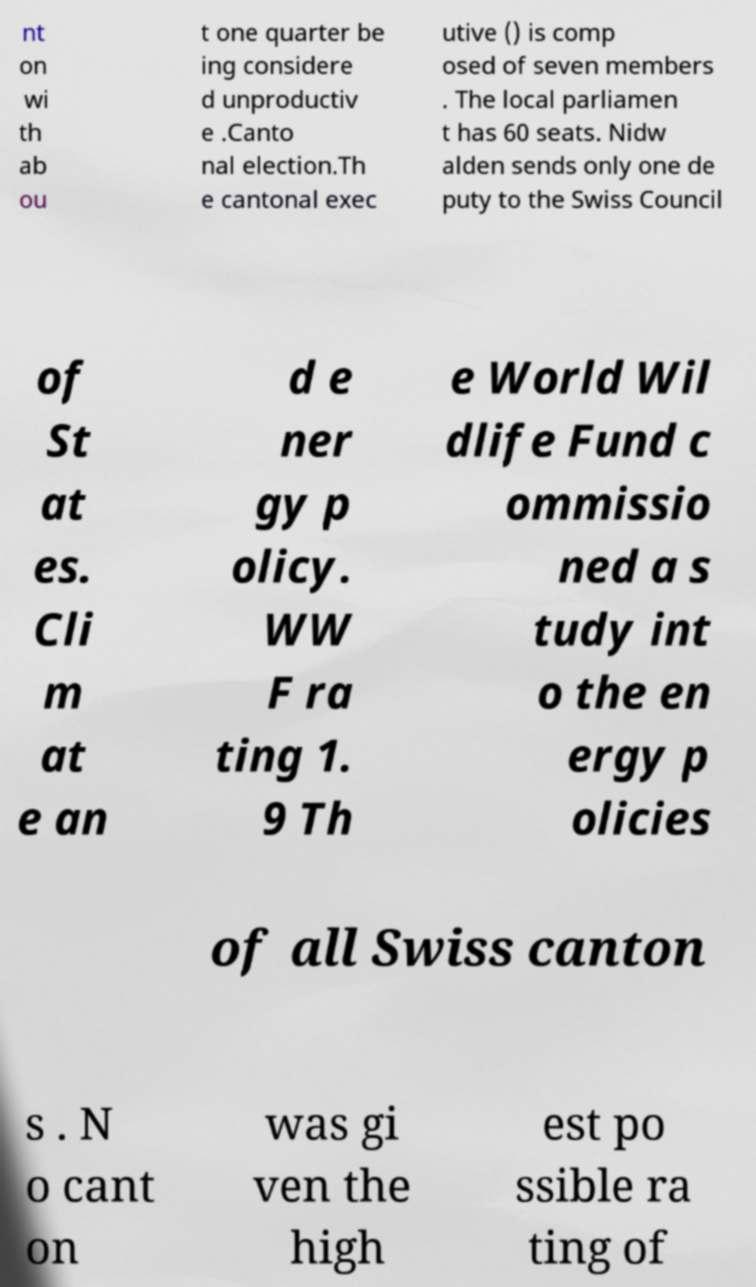I need the written content from this picture converted into text. Can you do that? nt on wi th ab ou t one quarter be ing considere d unproductiv e .Canto nal election.Th e cantonal exec utive () is comp osed of seven members . The local parliamen t has 60 seats. Nidw alden sends only one de puty to the Swiss Council of St at es. Cli m at e an d e ner gy p olicy. WW F ra ting 1. 9 Th e World Wil dlife Fund c ommissio ned a s tudy int o the en ergy p olicies of all Swiss canton s . N o cant on was gi ven the high est po ssible ra ting of 